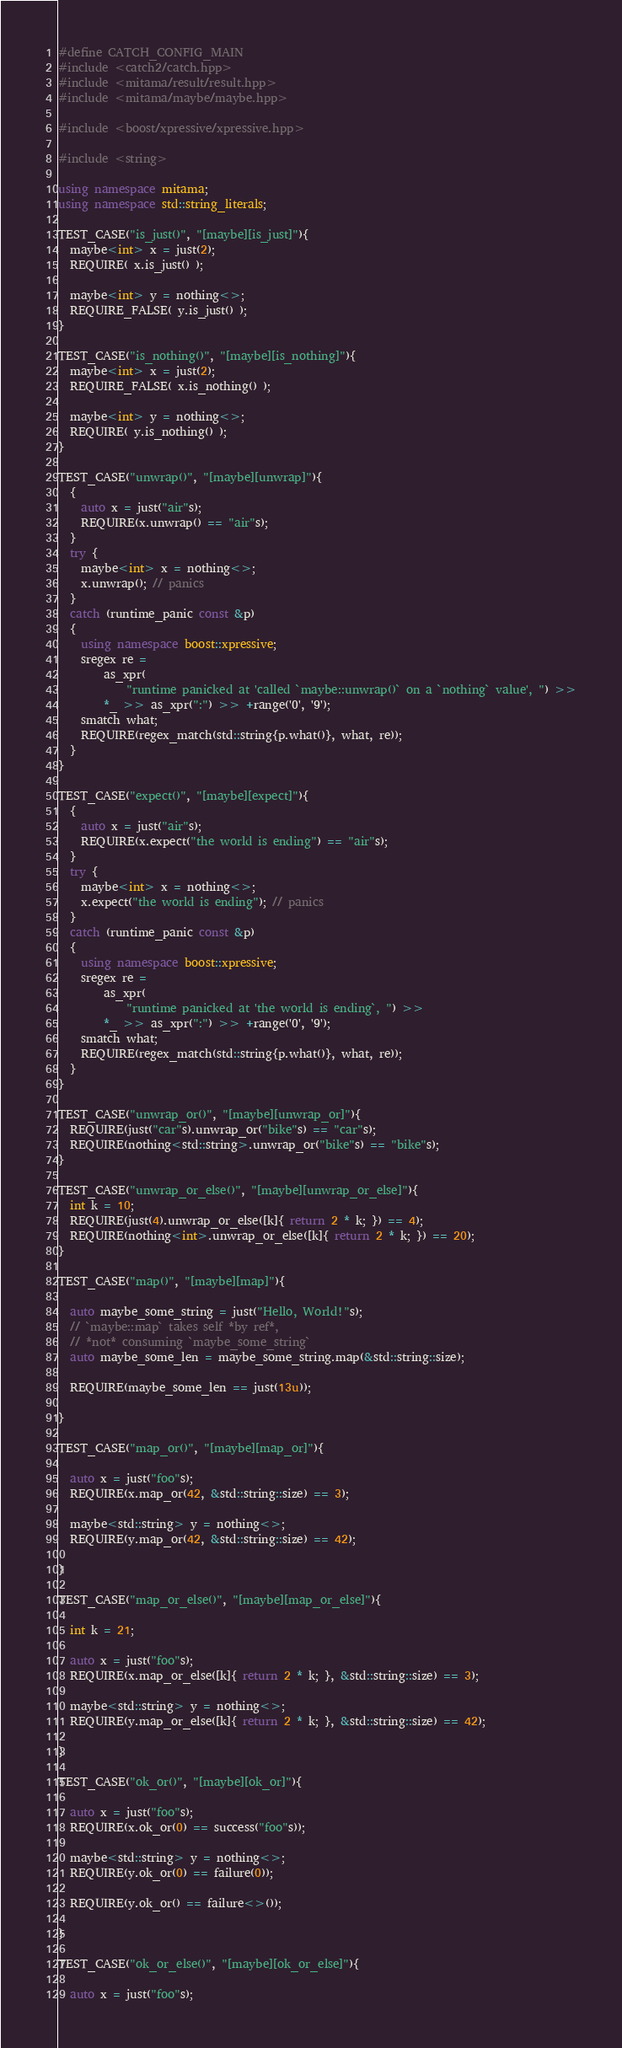<code> <loc_0><loc_0><loc_500><loc_500><_C++_>#define CATCH_CONFIG_MAIN
#include <catch2/catch.hpp>
#include <mitama/result/result.hpp>
#include <mitama/maybe/maybe.hpp>

#include <boost/xpressive/xpressive.hpp>

#include <string>

using namespace mitama;
using namespace std::string_literals;

TEST_CASE("is_just()", "[maybe][is_just]"){
  maybe<int> x = just(2);
  REQUIRE( x.is_just() );

  maybe<int> y = nothing<>;
  REQUIRE_FALSE( y.is_just() );
}

TEST_CASE("is_nothing()", "[maybe][is_nothing]"){
  maybe<int> x = just(2);
  REQUIRE_FALSE( x.is_nothing() );

  maybe<int> y = nothing<>;
  REQUIRE( y.is_nothing() );
}

TEST_CASE("unwrap()", "[maybe][unwrap]"){
  {
    auto x = just("air"s);
    REQUIRE(x.unwrap() == "air"s);
  }
  try {
    maybe<int> x = nothing<>;
    x.unwrap(); // panics
  }
  catch (runtime_panic const &p)
  {
    using namespace boost::xpressive;
    sregex re =
        as_xpr(
            "runtime panicked at 'called `maybe::unwrap()` on a `nothing` value', ") >>
        *_ >> as_xpr(":") >> +range('0', '9');
    smatch what;
    REQUIRE(regex_match(std::string{p.what()}, what, re));
  }
}

TEST_CASE("expect()", "[maybe][expect]"){
  {
    auto x = just("air"s);
    REQUIRE(x.expect("the world is ending") == "air"s);
  }
  try {
    maybe<int> x = nothing<>;
    x.expect("the world is ending"); // panics
  }
  catch (runtime_panic const &p)
  {
    using namespace boost::xpressive;
    sregex re =
        as_xpr(
            "runtime panicked at 'the world is ending`, ") >>
        *_ >> as_xpr(":") >> +range('0', '9');
    smatch what;
    REQUIRE(regex_match(std::string{p.what()}, what, re));
  }
}

TEST_CASE("unwrap_or()", "[maybe][unwrap_or]"){
  REQUIRE(just("car"s).unwrap_or("bike"s) == "car"s);
  REQUIRE(nothing<std::string>.unwrap_or("bike"s) == "bike"s);
}

TEST_CASE("unwrap_or_else()", "[maybe][unwrap_or_else]"){
  int k = 10;
  REQUIRE(just(4).unwrap_or_else([k]{ return 2 * k; }) == 4);
  REQUIRE(nothing<int>.unwrap_or_else([k]{ return 2 * k; }) == 20);
}

TEST_CASE("map()", "[maybe][map]"){

  auto maybe_some_string = just("Hello, World!"s);
  // `maybe::map` takes self *by ref*,
  // *not* consuming `maybe_some_string`
  auto maybe_some_len = maybe_some_string.map(&std::string::size);

  REQUIRE(maybe_some_len == just(13u));

}

TEST_CASE("map_or()", "[maybe][map_or]"){

  auto x = just("foo"s);
  REQUIRE(x.map_or(42, &std::string::size) == 3);

  maybe<std::string> y = nothing<>;
  REQUIRE(y.map_or(42, &std::string::size) == 42);

}

TEST_CASE("map_or_else()", "[maybe][map_or_else]"){

  int k = 21;

  auto x = just("foo"s);
  REQUIRE(x.map_or_else([k]{ return 2 * k; }, &std::string::size) == 3);

  maybe<std::string> y = nothing<>;
  REQUIRE(y.map_or_else([k]{ return 2 * k; }, &std::string::size) == 42);

}

TEST_CASE("ok_or()", "[maybe][ok_or]"){

  auto x = just("foo"s);
  REQUIRE(x.ok_or(0) == success("foo"s));

  maybe<std::string> y = nothing<>;
  REQUIRE(y.ok_or(0) == failure(0));

  REQUIRE(y.ok_or() == failure<>());

}

TEST_CASE("ok_or_else()", "[maybe][ok_or_else]"){

  auto x = just("foo"s);</code> 